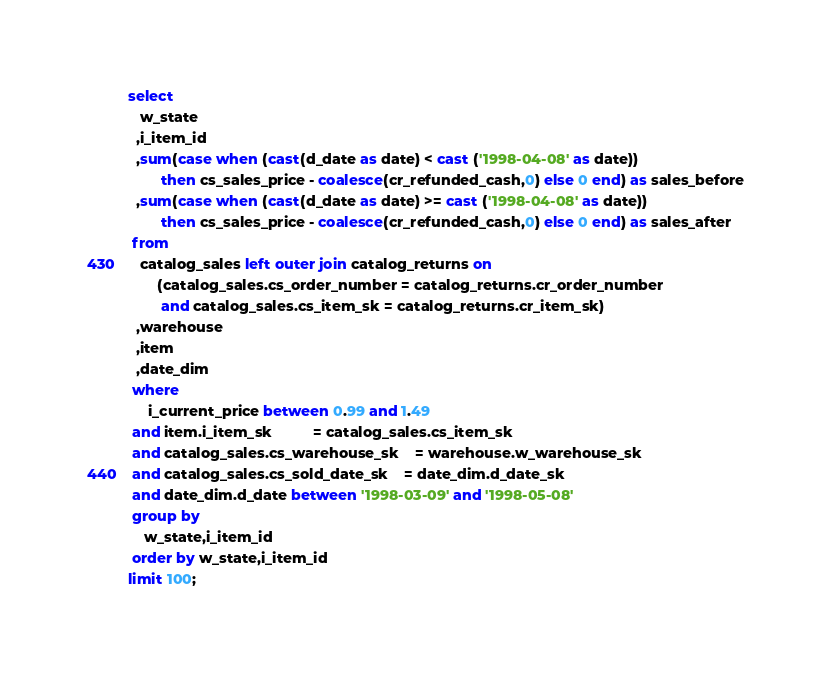Convert code to text. <code><loc_0><loc_0><loc_500><loc_500><_SQL_>select  
   w_state
  ,i_item_id
  ,sum(case when (cast(d_date as date) < cast ('1998-04-08' as date)) 
 		then cs_sales_price - coalesce(cr_refunded_cash,0) else 0 end) as sales_before
  ,sum(case when (cast(d_date as date) >= cast ('1998-04-08' as date)) 
 		then cs_sales_price - coalesce(cr_refunded_cash,0) else 0 end) as sales_after
 from
   catalog_sales left outer join catalog_returns on
       (catalog_sales.cs_order_number = catalog_returns.cr_order_number 
        and catalog_sales.cs_item_sk = catalog_returns.cr_item_sk)
  ,warehouse 
  ,item
  ,date_dim
 where
     i_current_price between 0.99 and 1.49
 and item.i_item_sk          = catalog_sales.cs_item_sk
 and catalog_sales.cs_warehouse_sk    = warehouse.w_warehouse_sk 
 and catalog_sales.cs_sold_date_sk    = date_dim.d_date_sk
 and date_dim.d_date between '1998-03-09' and '1998-05-08'
 group by
    w_state,i_item_id
 order by w_state,i_item_id
limit 100;


</code> 